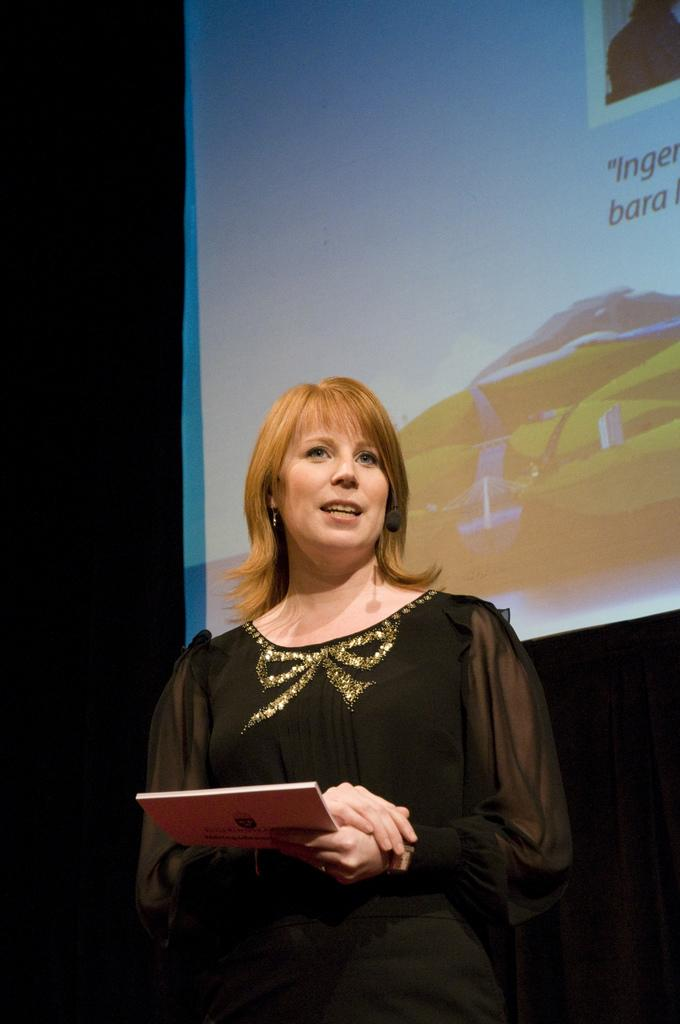Who is the main subject in the image? There is a woman in the image. What is the woman holding in the image? The woman is holding a book. What can be seen behind the woman in the image? There is a screen visible behind the woman. What type of screw can be seen on the woman's wrist in the image? There is no screw visible on the woman's wrist in the image. 